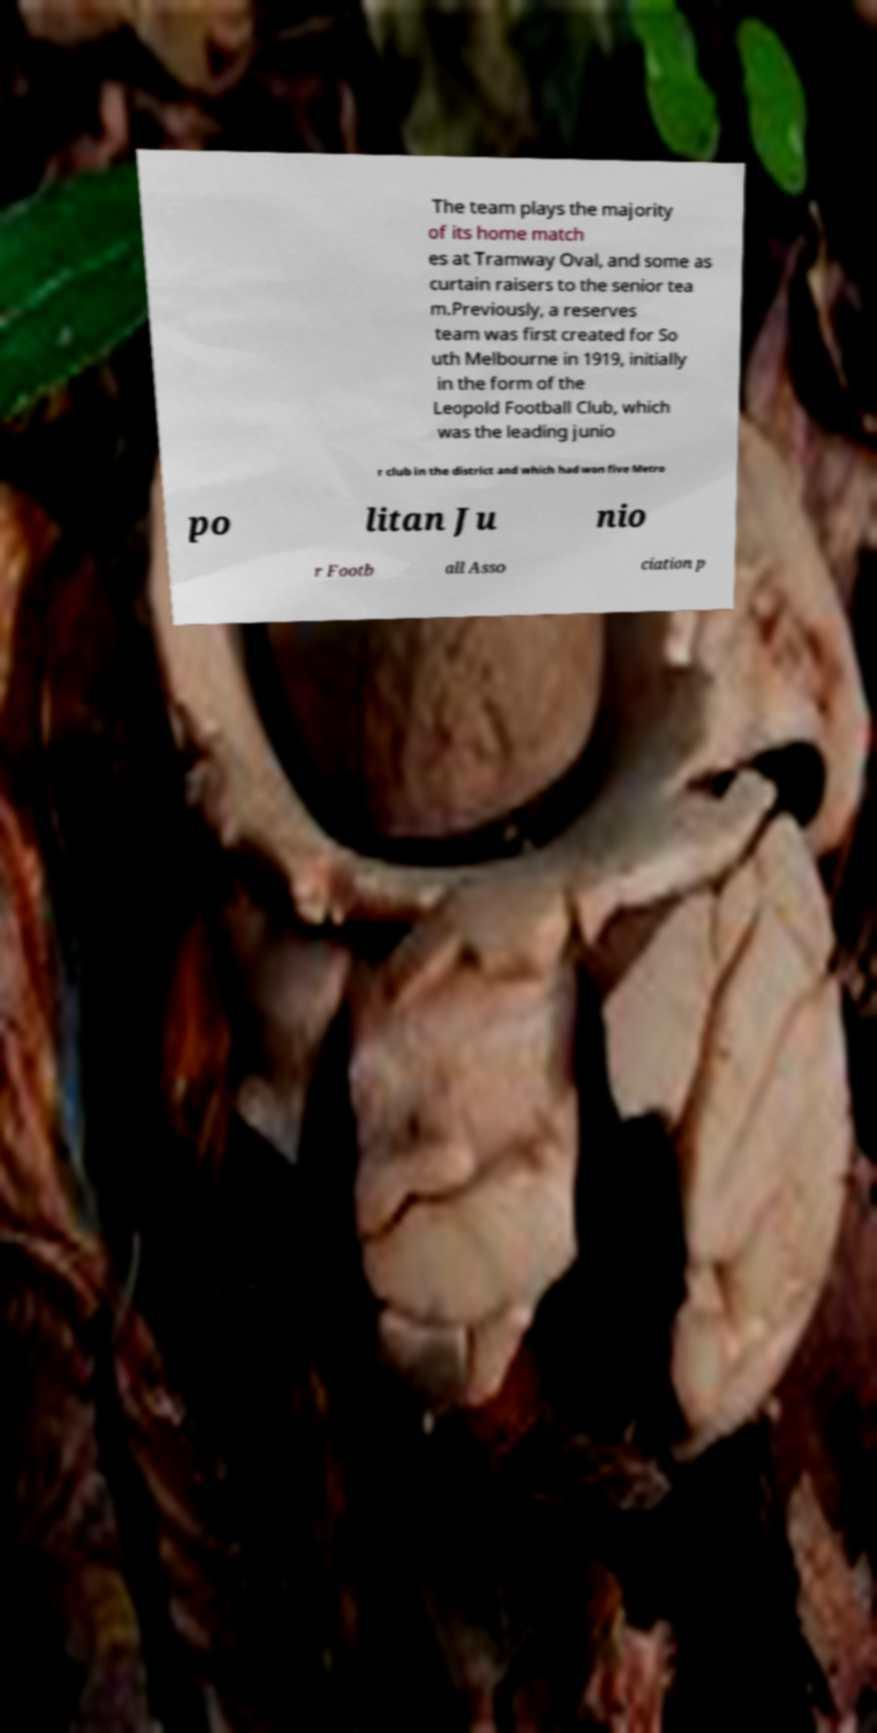What messages or text are displayed in this image? I need them in a readable, typed format. The team plays the majority of its home match es at Tramway Oval, and some as curtain raisers to the senior tea m.Previously, a reserves team was first created for So uth Melbourne in 1919, initially in the form of the Leopold Football Club, which was the leading junio r club in the district and which had won five Metro po litan Ju nio r Footb all Asso ciation p 